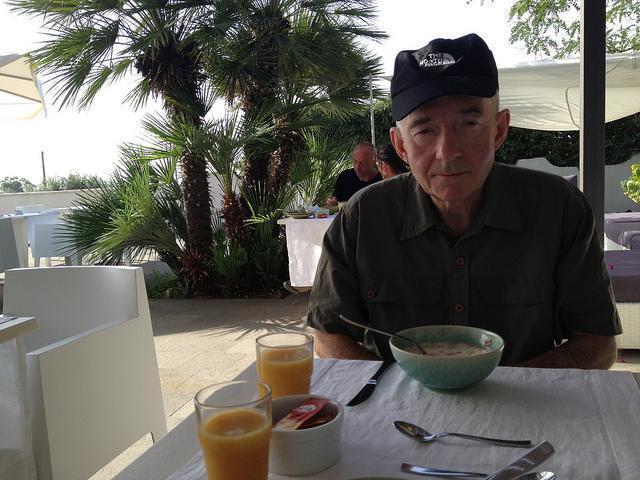What time of day does this man dine here?
From the following set of four choices, select the accurate answer to respond to the question.
Options: Noon, night, morning, evening. Morning. 